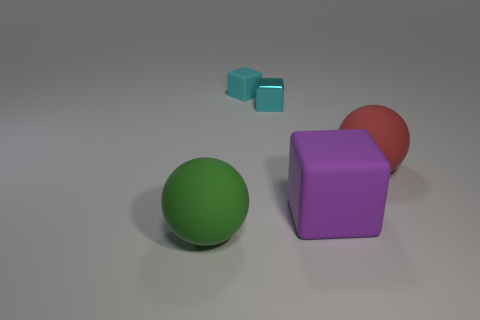Do the tiny rubber thing and the metallic object have the same color?
Offer a very short reply. Yes. There is a cyan thing that is the same material as the large purple object; what size is it?
Your answer should be compact. Small. There is a small thing that is in front of the matte cube that is on the left side of the tiny metal block; what number of red matte spheres are in front of it?
Offer a terse response. 1. Does the small matte block have the same color as the small object that is right of the small cyan matte block?
Your answer should be very brief. Yes. There is a ball that is right of the object that is in front of the block in front of the red sphere; what is it made of?
Provide a succinct answer. Rubber. There is a matte thing that is behind the large red rubber object; does it have the same shape as the tiny metallic thing?
Offer a very short reply. Yes. There is a big ball in front of the red object; what is its material?
Ensure brevity in your answer.  Rubber. How many shiny objects are either balls or small objects?
Offer a very short reply. 1. Are there any green matte balls of the same size as the red matte object?
Offer a terse response. Yes. Is the number of cyan matte blocks behind the green thing greater than the number of small green metallic balls?
Your response must be concise. Yes. 